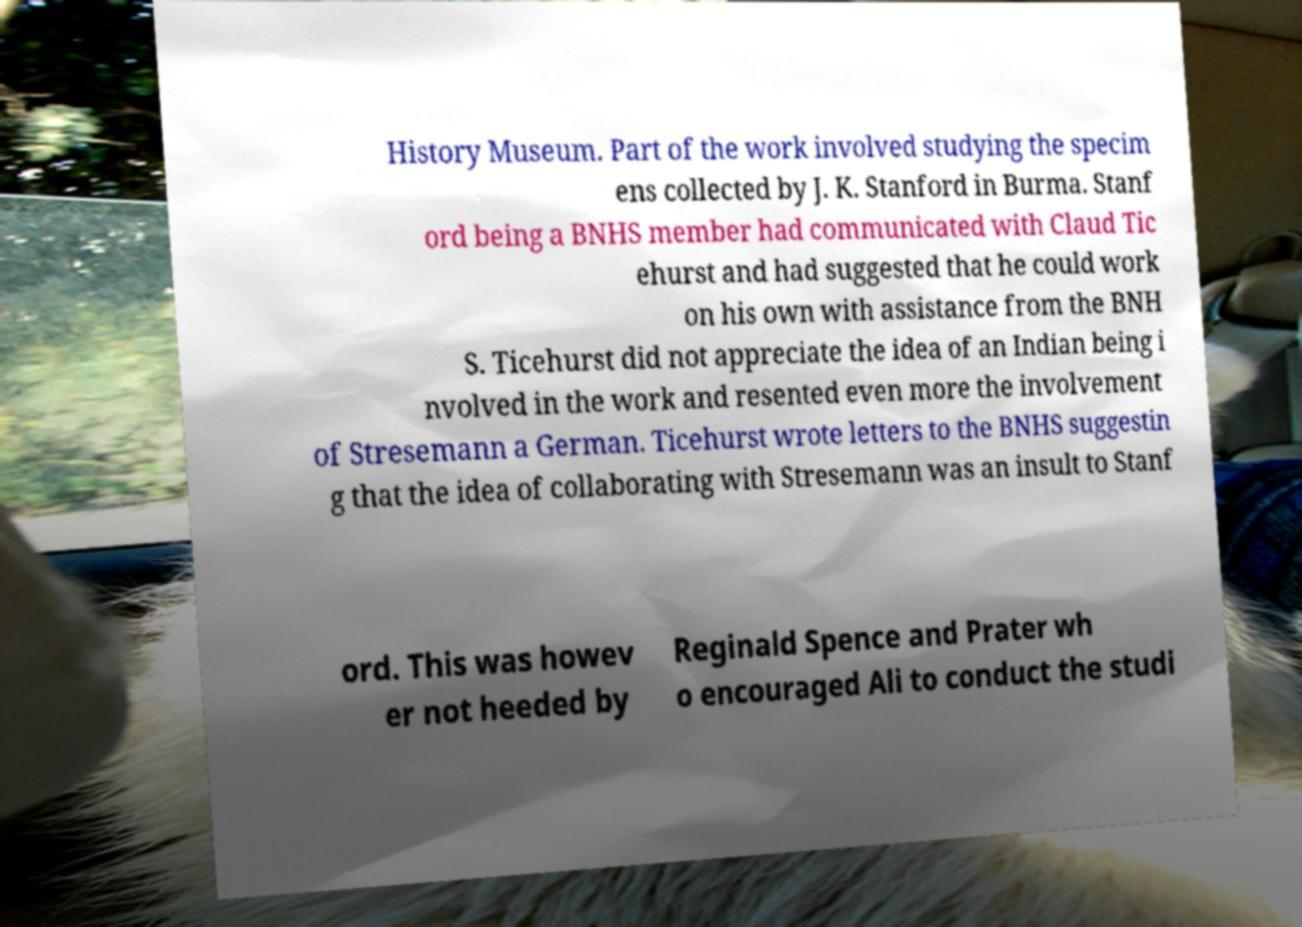What messages or text are displayed in this image? I need them in a readable, typed format. History Museum. Part of the work involved studying the specim ens collected by J. K. Stanford in Burma. Stanf ord being a BNHS member had communicated with Claud Tic ehurst and had suggested that he could work on his own with assistance from the BNH S. Ticehurst did not appreciate the idea of an Indian being i nvolved in the work and resented even more the involvement of Stresemann a German. Ticehurst wrote letters to the BNHS suggestin g that the idea of collaborating with Stresemann was an insult to Stanf ord. This was howev er not heeded by Reginald Spence and Prater wh o encouraged Ali to conduct the studi 